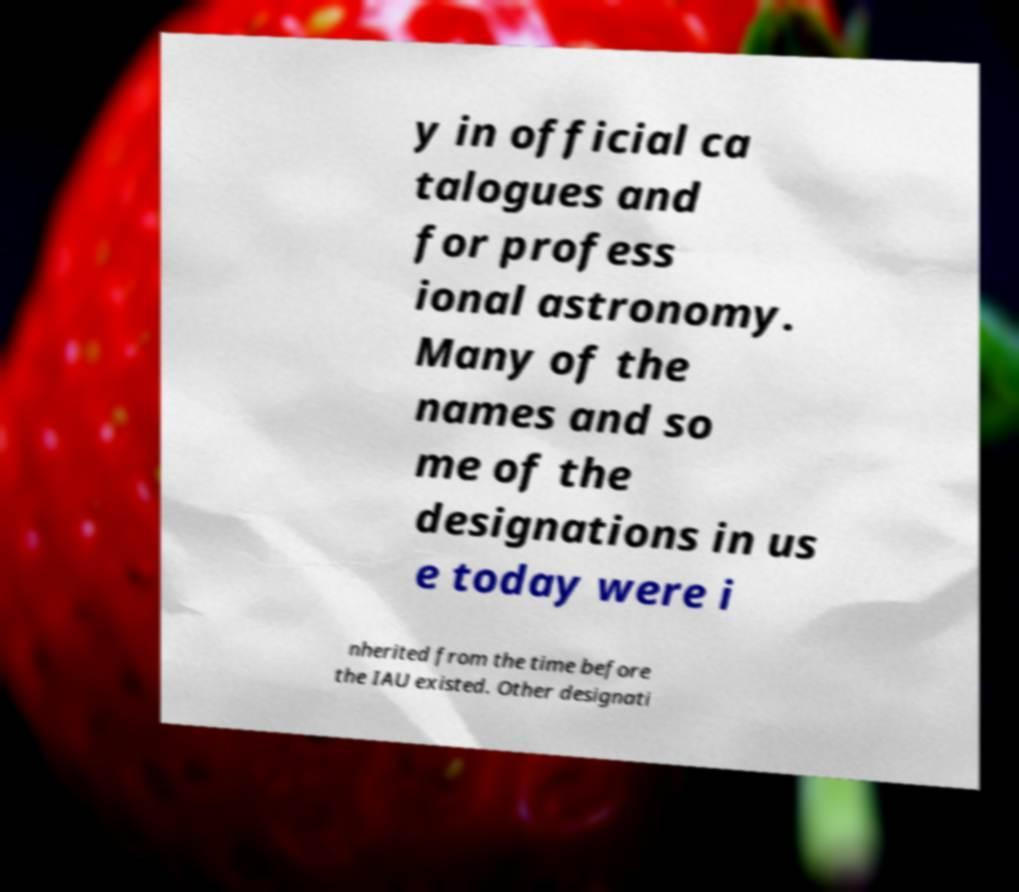Could you assist in decoding the text presented in this image and type it out clearly? y in official ca talogues and for profess ional astronomy. Many of the names and so me of the designations in us e today were i nherited from the time before the IAU existed. Other designati 